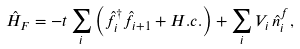Convert formula to latex. <formula><loc_0><loc_0><loc_500><loc_500>\hat { H } _ { F } = - t \sum _ { i } \left ( \hat { f } ^ { \dagger } _ { i } \hat { f } _ { i + 1 } + H . c . \right ) + \sum _ { i } V _ { i } \, \hat { n } ^ { f } _ { i } ,</formula> 